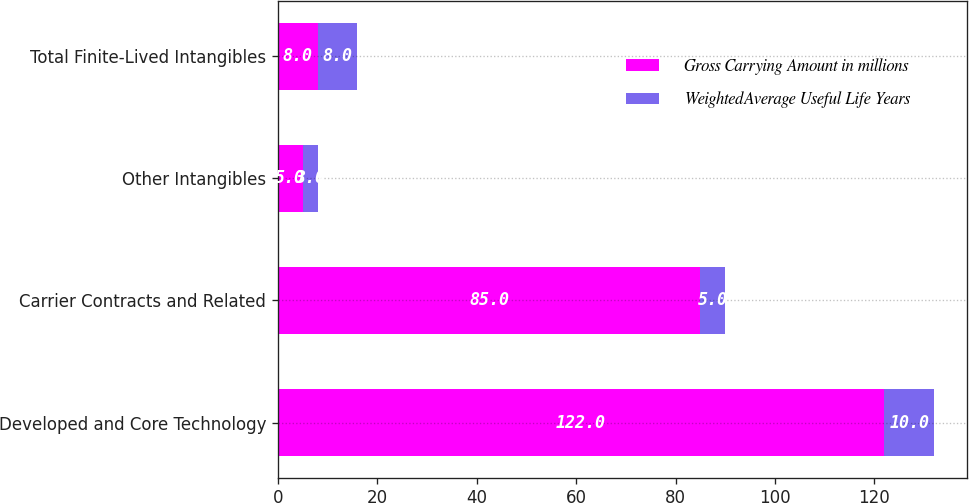Convert chart to OTSL. <chart><loc_0><loc_0><loc_500><loc_500><stacked_bar_chart><ecel><fcel>Developed and Core Technology<fcel>Carrier Contracts and Related<fcel>Other Intangibles<fcel>Total Finite-Lived Intangibles<nl><fcel>Gross Carrying Amount in millions<fcel>122<fcel>85<fcel>5<fcel>8<nl><fcel>WeightedAverage Useful Life Years<fcel>10<fcel>5<fcel>3<fcel>8<nl></chart> 